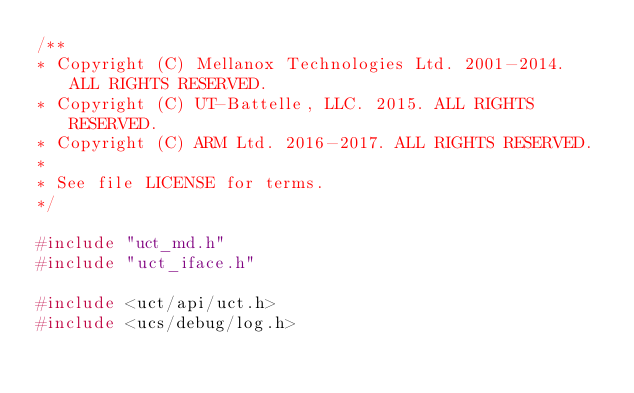<code> <loc_0><loc_0><loc_500><loc_500><_C_>/**
* Copyright (C) Mellanox Technologies Ltd. 2001-2014.  ALL RIGHTS RESERVED.
* Copyright (C) UT-Battelle, LLC. 2015. ALL RIGHTS RESERVED.
* Copyright (C) ARM Ltd. 2016-2017. ALL RIGHTS RESERVED.
*
* See file LICENSE for terms.
*/

#include "uct_md.h"
#include "uct_iface.h"

#include <uct/api/uct.h>
#include <ucs/debug/log.h></code> 